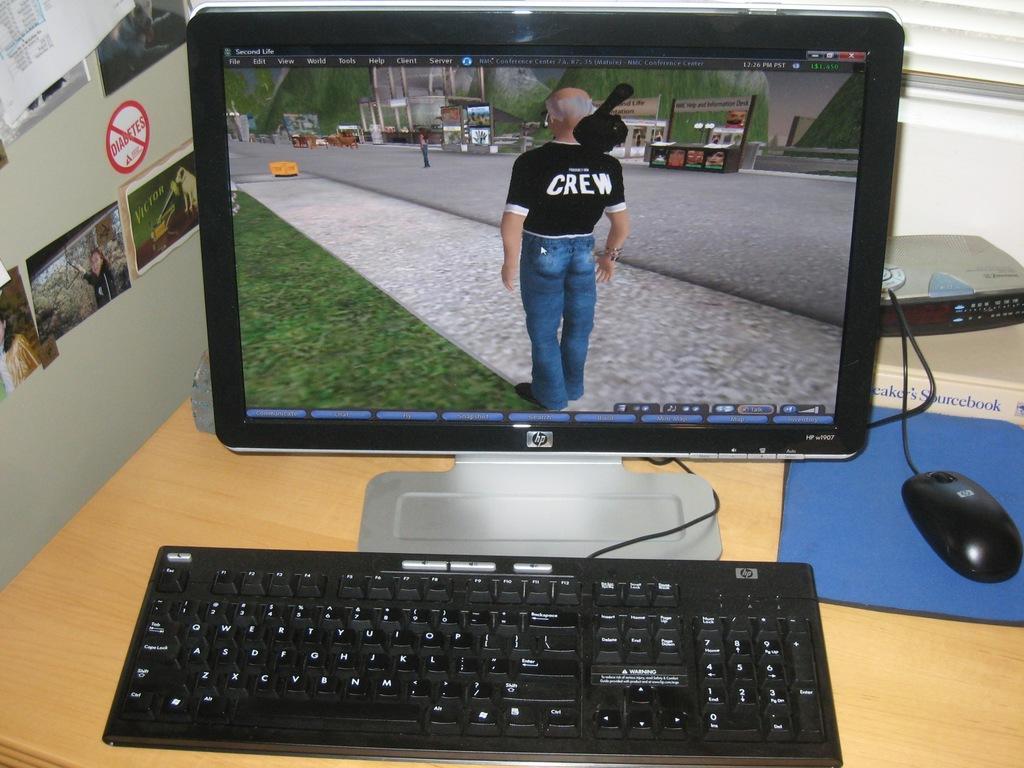Could you give a brief overview of what you see in this image? There is monitor, keyboard, mouse is present on the desk. There are photo frames on the wall, there a person is standing on the road. 